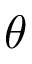Convert formula to latex. <formula><loc_0><loc_0><loc_500><loc_500>\theta</formula> 